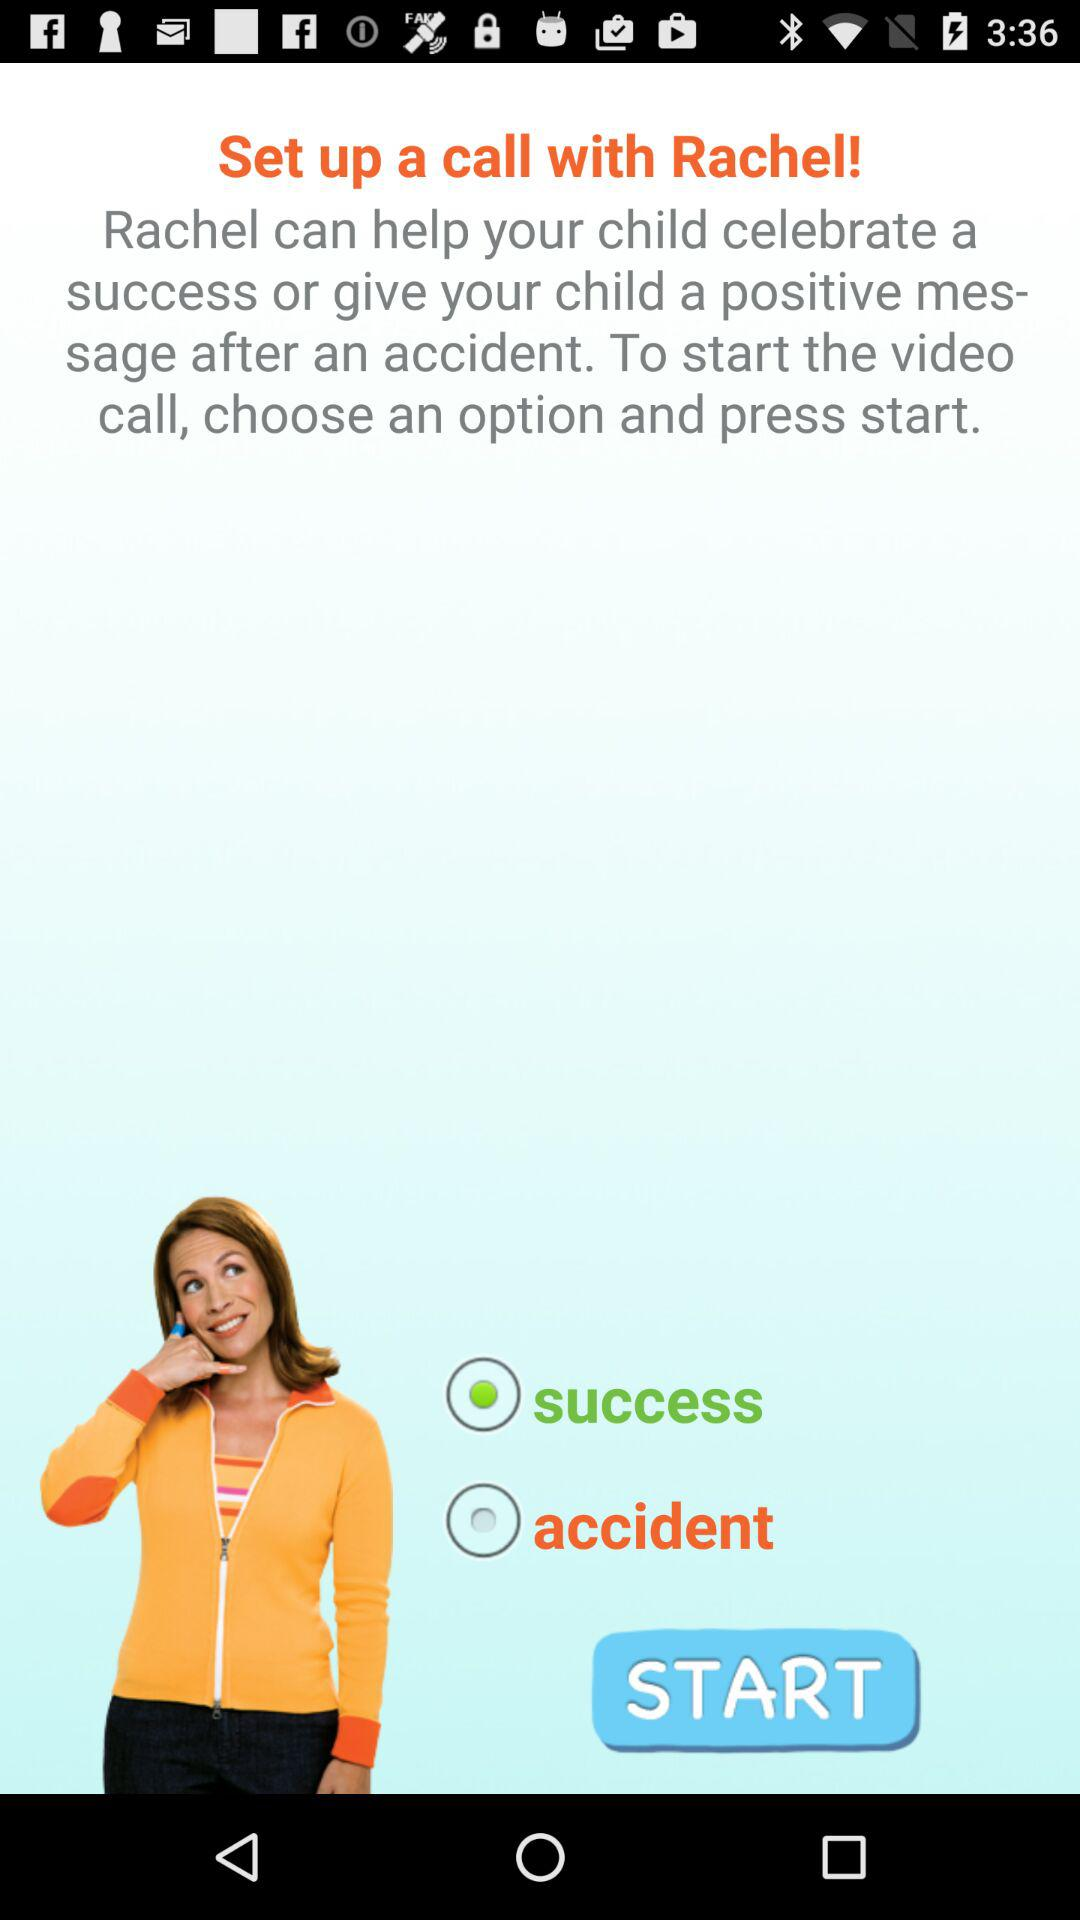Is accident selected or not?
When the provided information is insufficient, respond with <no answer>. <no answer> 